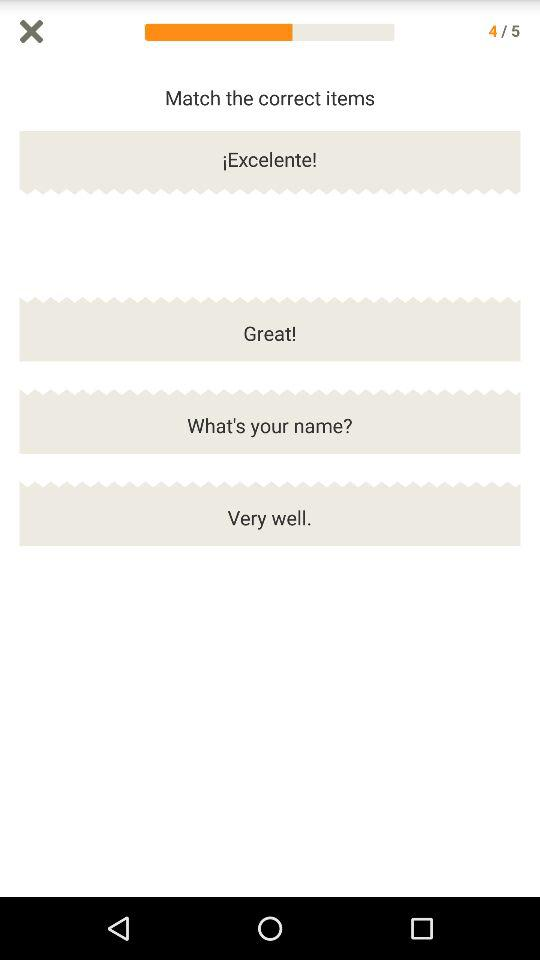What are the available options? The available options are "Great!", "What's your name?" and "Very well.". 